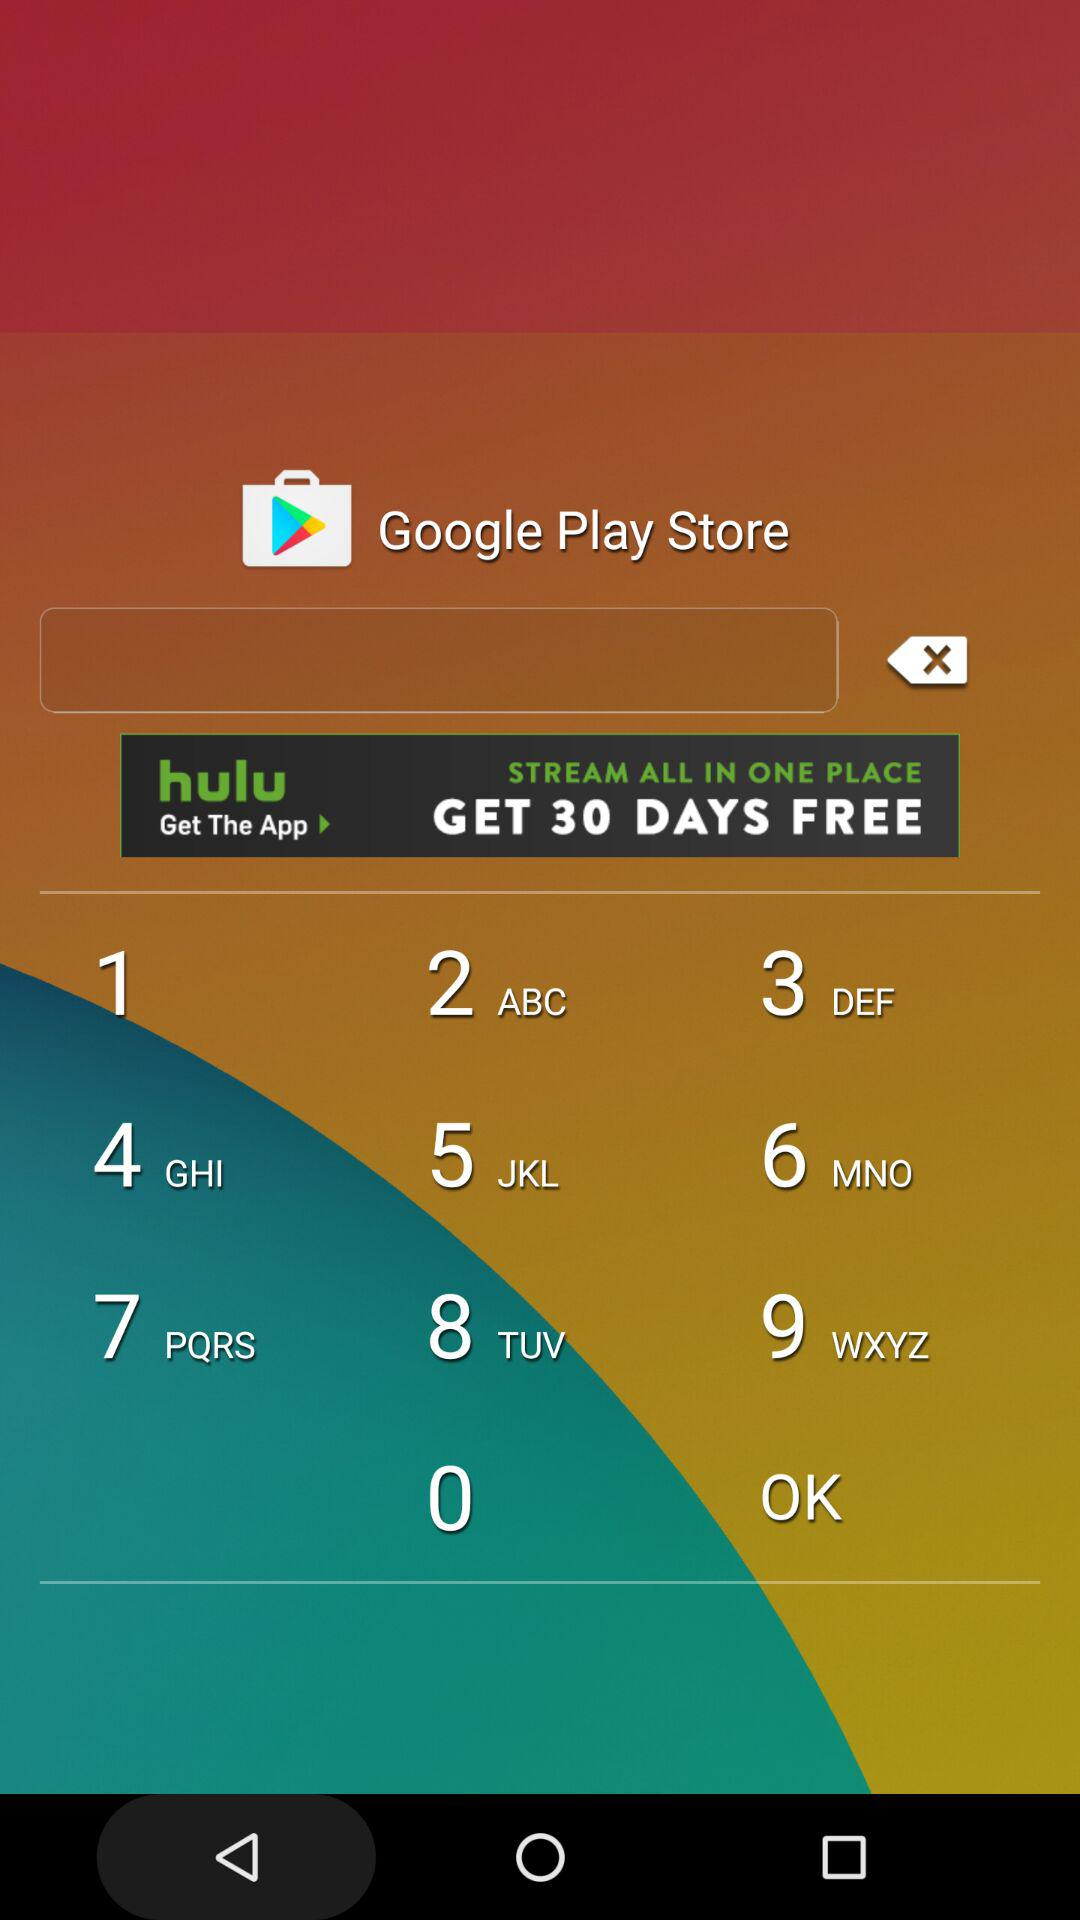How much is the purse for starter allowance? The purse for the starter allowance is worth $40,000. 